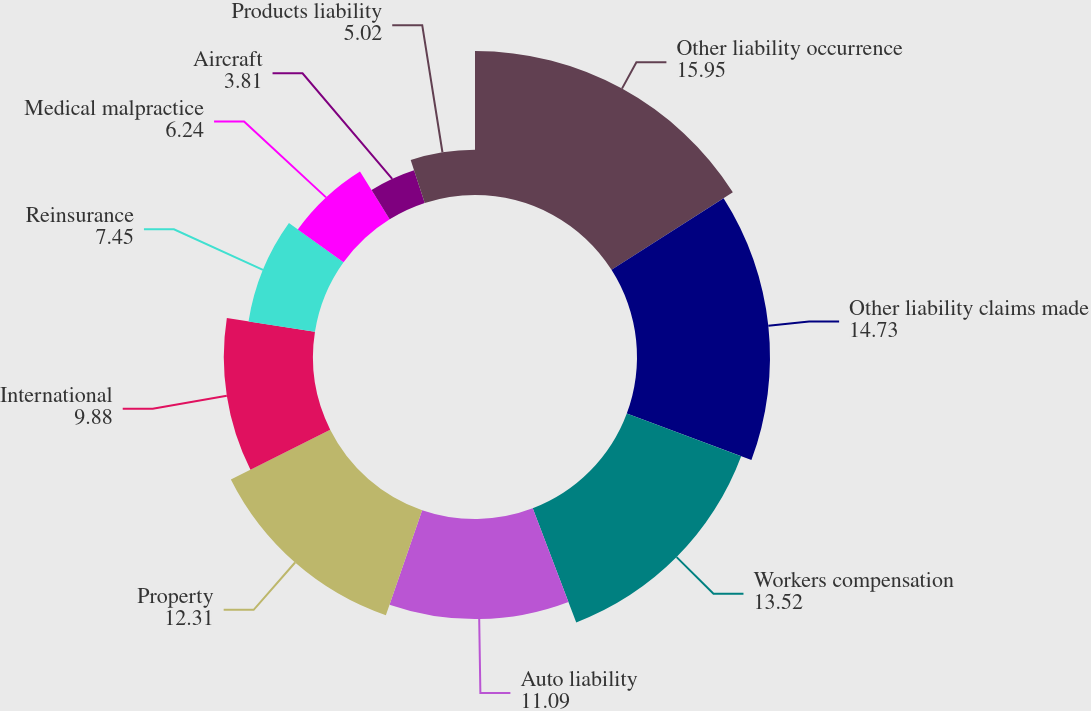<chart> <loc_0><loc_0><loc_500><loc_500><pie_chart><fcel>Other liability occurrence<fcel>Other liability claims made<fcel>Workers compensation<fcel>Auto liability<fcel>Property<fcel>International<fcel>Reinsurance<fcel>Medical malpractice<fcel>Aircraft<fcel>Products liability<nl><fcel>15.95%<fcel>14.73%<fcel>13.52%<fcel>11.09%<fcel>12.31%<fcel>9.88%<fcel>7.45%<fcel>6.24%<fcel>3.81%<fcel>5.02%<nl></chart> 